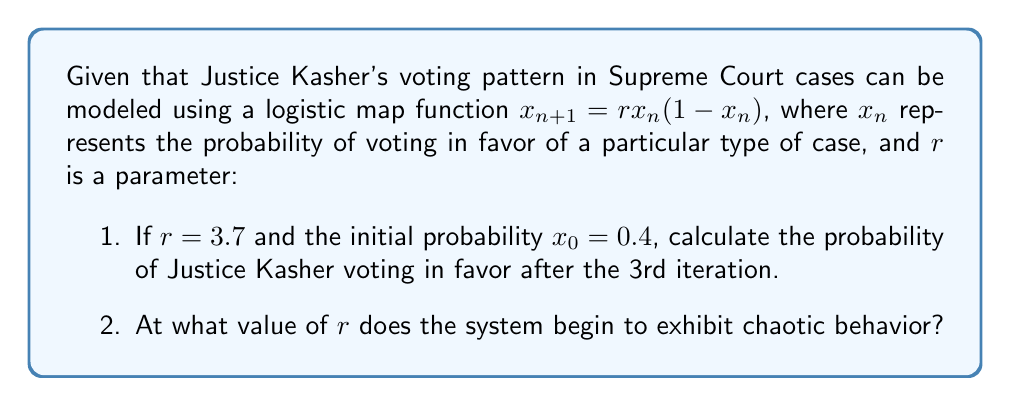Help me with this question. 1. To calculate the probability after the 3rd iteration, we need to apply the logistic map function three times:

   First iteration:
   $x_1 = 3.7 \cdot 0.4 \cdot (1-0.4) = 0.888$

   Second iteration:
   $x_2 = 3.7 \cdot 0.888 \cdot (1-0.888) = 0.3678$

   Third iteration:
   $x_3 = 3.7 \cdot 0.3678 \cdot (1-0.3678) = 0.8618$

   Therefore, the probability after the 3rd iteration is approximately 0.8618 or 86.18%.

2. In the logistic map, chaotic behavior begins when $r > 3.57$. This is known as the onset of chaos in the logistic map. At this point, the system becomes sensitive to initial conditions and exhibits aperiodic behavior, which are key characteristics of chaos.

   The progression to chaos in the logistic map occurs as follows:
   - For $0 < r < 1$, the population will eventually die out.
   - For $1 < r < 3$, the population will quickly approach a stable value.
   - For $3 < r < 3.57$, the population will oscillate between two or more values.
   - For $r > 3.57$, the population will exhibit chaotic behavior.

   The value $r = 3.57$ is approximately where the period-doubling cascade ends and chaos begins. This point is also known as the accumulation point of the period-doubling bifurcations.
Answer: 1. 0.8618
2. 3.57 